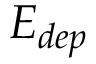<formula> <loc_0><loc_0><loc_500><loc_500>E _ { d e p }</formula> 